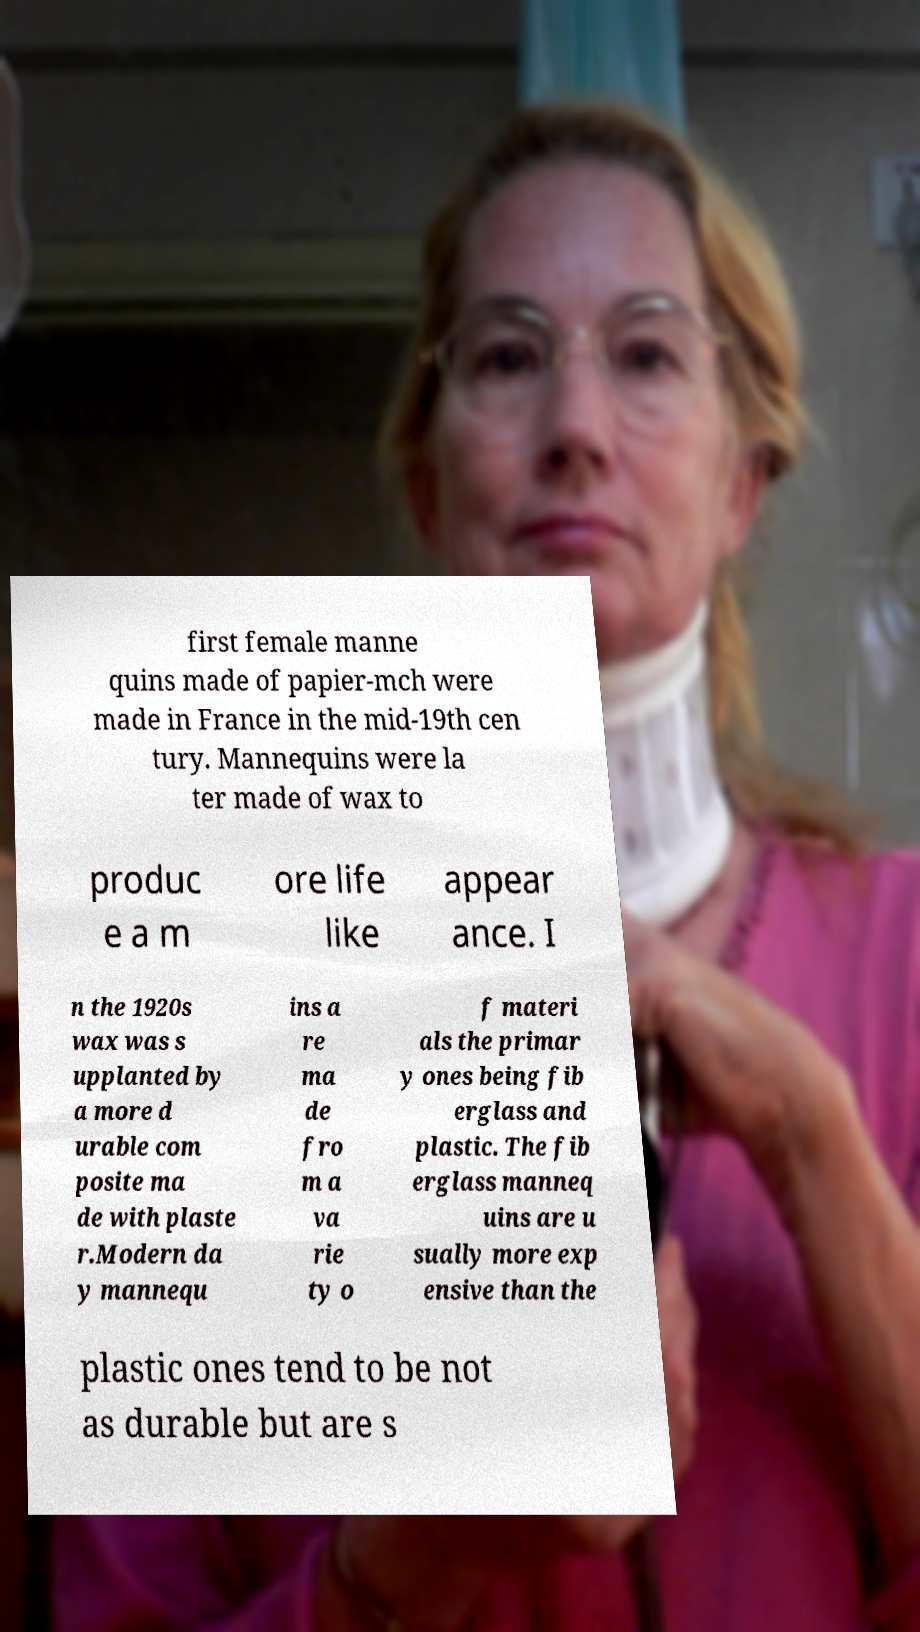I need the written content from this picture converted into text. Can you do that? first female manne quins made of papier-mch were made in France in the mid-19th cen tury. Mannequins were la ter made of wax to produc e a m ore life like appear ance. I n the 1920s wax was s upplanted by a more d urable com posite ma de with plaste r.Modern da y mannequ ins a re ma de fro m a va rie ty o f materi als the primar y ones being fib erglass and plastic. The fib erglass manneq uins are u sually more exp ensive than the plastic ones tend to be not as durable but are s 